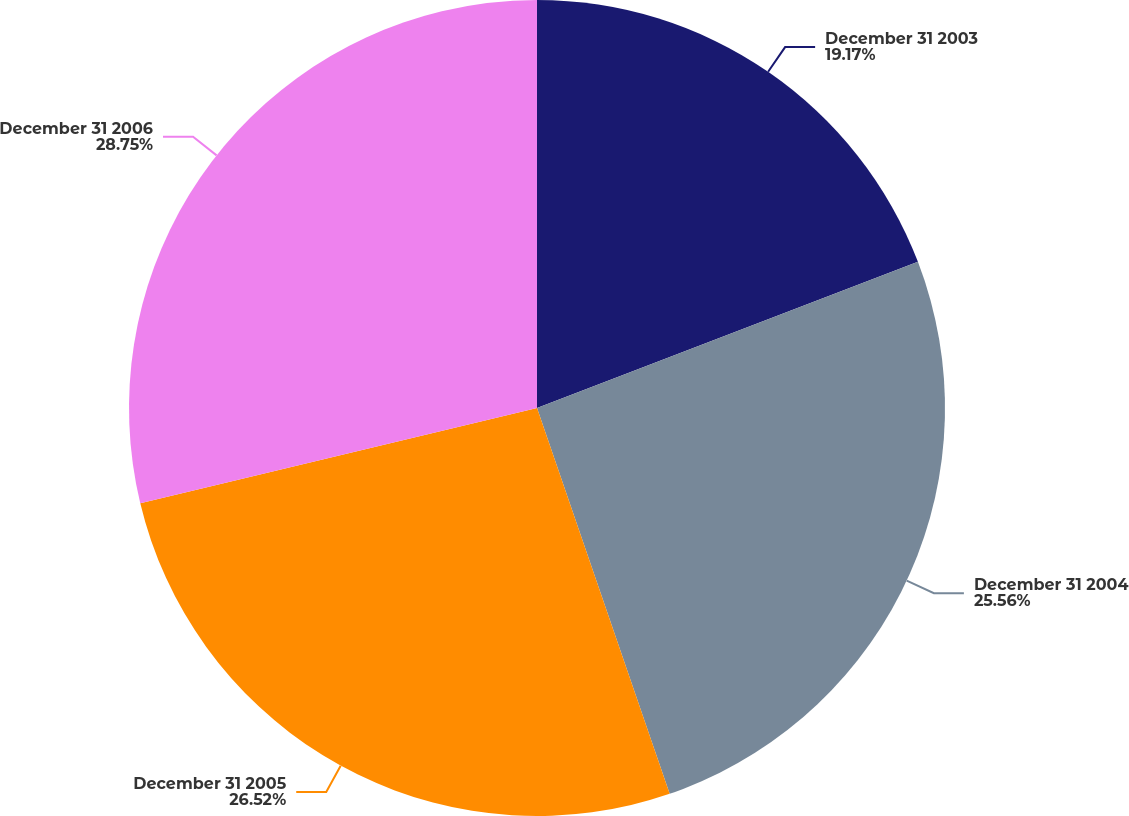Convert chart. <chart><loc_0><loc_0><loc_500><loc_500><pie_chart><fcel>December 31 2003<fcel>December 31 2004<fcel>December 31 2005<fcel>December 31 2006<nl><fcel>19.17%<fcel>25.56%<fcel>26.52%<fcel>28.75%<nl></chart> 